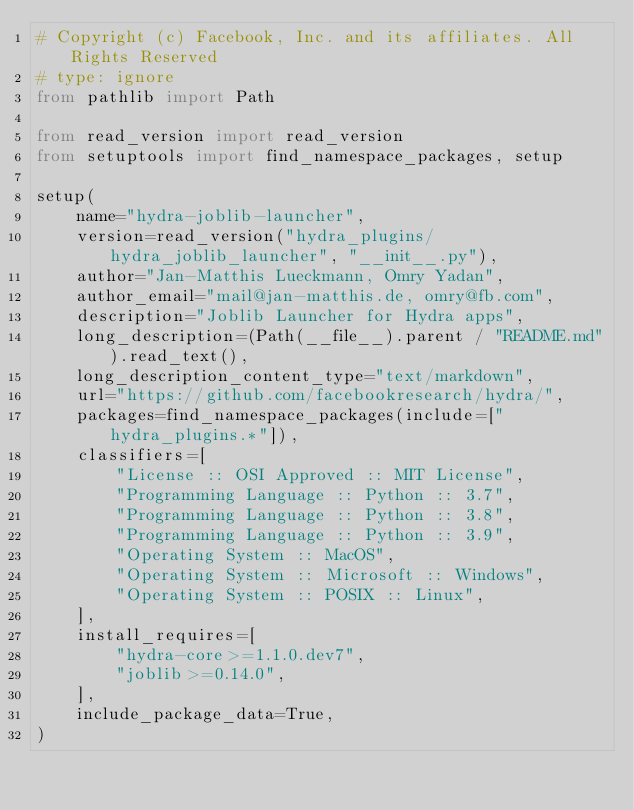Convert code to text. <code><loc_0><loc_0><loc_500><loc_500><_Python_># Copyright (c) Facebook, Inc. and its affiliates. All Rights Reserved
# type: ignore
from pathlib import Path

from read_version import read_version
from setuptools import find_namespace_packages, setup

setup(
    name="hydra-joblib-launcher",
    version=read_version("hydra_plugins/hydra_joblib_launcher", "__init__.py"),
    author="Jan-Matthis Lueckmann, Omry Yadan",
    author_email="mail@jan-matthis.de, omry@fb.com",
    description="Joblib Launcher for Hydra apps",
    long_description=(Path(__file__).parent / "README.md").read_text(),
    long_description_content_type="text/markdown",
    url="https://github.com/facebookresearch/hydra/",
    packages=find_namespace_packages(include=["hydra_plugins.*"]),
    classifiers=[
        "License :: OSI Approved :: MIT License",
        "Programming Language :: Python :: 3.7",
        "Programming Language :: Python :: 3.8",
        "Programming Language :: Python :: 3.9",
        "Operating System :: MacOS",
        "Operating System :: Microsoft :: Windows",
        "Operating System :: POSIX :: Linux",
    ],
    install_requires=[
        "hydra-core>=1.1.0.dev7",
        "joblib>=0.14.0",
    ],
    include_package_data=True,
)
</code> 